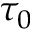Convert formula to latex. <formula><loc_0><loc_0><loc_500><loc_500>\tau _ { 0 }</formula> 